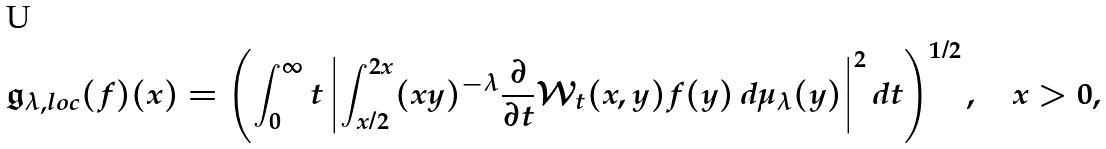Convert formula to latex. <formula><loc_0><loc_0><loc_500><loc_500>\mathfrak { g } _ { \lambda , l o c } ( f ) ( x ) = \left ( \int _ { 0 } ^ { \infty } t \left | \int _ { x / 2 } ^ { 2 x } ( x y ) ^ { - \lambda } \frac { \partial } { \partial t } \mathcal { W } _ { t } ( x , y ) f ( y ) \, d \mu _ { \lambda } ( y ) \right | ^ { 2 } d t \right ) ^ { 1 / 2 } , \quad x > 0 ,</formula> 